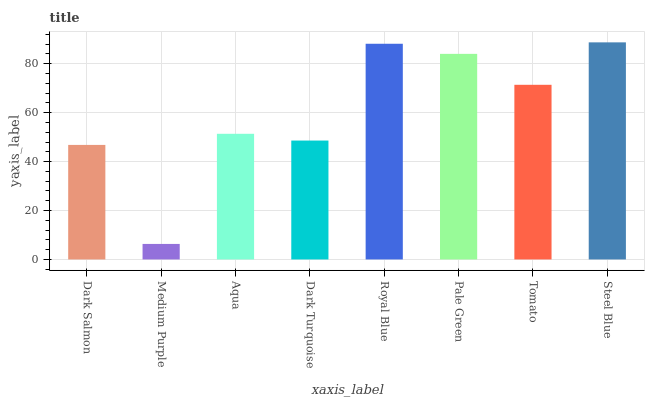Is Medium Purple the minimum?
Answer yes or no. Yes. Is Steel Blue the maximum?
Answer yes or no. Yes. Is Aqua the minimum?
Answer yes or no. No. Is Aqua the maximum?
Answer yes or no. No. Is Aqua greater than Medium Purple?
Answer yes or no. Yes. Is Medium Purple less than Aqua?
Answer yes or no. Yes. Is Medium Purple greater than Aqua?
Answer yes or no. No. Is Aqua less than Medium Purple?
Answer yes or no. No. Is Tomato the high median?
Answer yes or no. Yes. Is Aqua the low median?
Answer yes or no. Yes. Is Medium Purple the high median?
Answer yes or no. No. Is Dark Turquoise the low median?
Answer yes or no. No. 